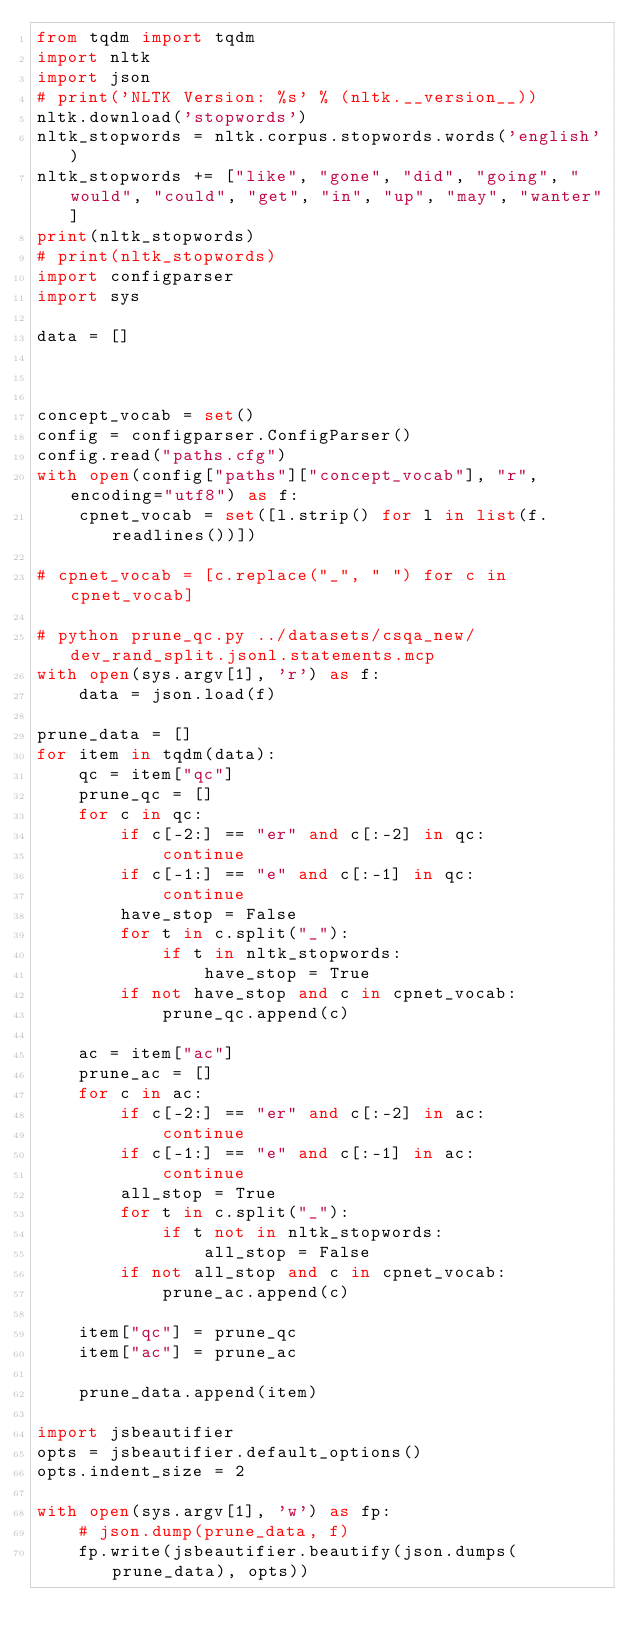Convert code to text. <code><loc_0><loc_0><loc_500><loc_500><_Python_>from tqdm import tqdm
import nltk
import json
# print('NLTK Version: %s' % (nltk.__version__))
nltk.download('stopwords')
nltk_stopwords = nltk.corpus.stopwords.words('english')
nltk_stopwords += ["like", "gone", "did", "going", "would", "could", "get", "in", "up", "may", "wanter"]
print(nltk_stopwords)
# print(nltk_stopwords)
import configparser
import sys

data = []



concept_vocab = set()
config = configparser.ConfigParser()
config.read("paths.cfg")
with open(config["paths"]["concept_vocab"], "r", encoding="utf8") as f:
    cpnet_vocab = set([l.strip() for l in list(f.readlines())])

# cpnet_vocab = [c.replace("_", " ") for c in cpnet_vocab]

# python prune_qc.py ../datasets/csqa_new/dev_rand_split.jsonl.statements.mcp
with open(sys.argv[1], 'r') as f:
    data = json.load(f)

prune_data = []
for item in tqdm(data):
    qc = item["qc"]
    prune_qc = []
    for c in qc:
        if c[-2:] == "er" and c[:-2] in qc:
            continue
        if c[-1:] == "e" and c[:-1] in qc:
            continue
        have_stop = False
        for t in c.split("_"):
            if t in nltk_stopwords:
                have_stop = True
        if not have_stop and c in cpnet_vocab:
            prune_qc.append(c)

    ac = item["ac"]
    prune_ac = []
    for c in ac:
        if c[-2:] == "er" and c[:-2] in ac:
            continue
        if c[-1:] == "e" and c[:-1] in ac:
            continue
        all_stop = True
        for t in c.split("_"):
            if t not in nltk_stopwords:
                all_stop = False
        if not all_stop and c in cpnet_vocab:
            prune_ac.append(c)

    item["qc"] = prune_qc
    item["ac"] = prune_ac

    prune_data.append(item)

import jsbeautifier
opts = jsbeautifier.default_options()
opts.indent_size = 2

with open(sys.argv[1], 'w') as fp:
    # json.dump(prune_data, f)
    fp.write(jsbeautifier.beautify(json.dumps(prune_data), opts))</code> 